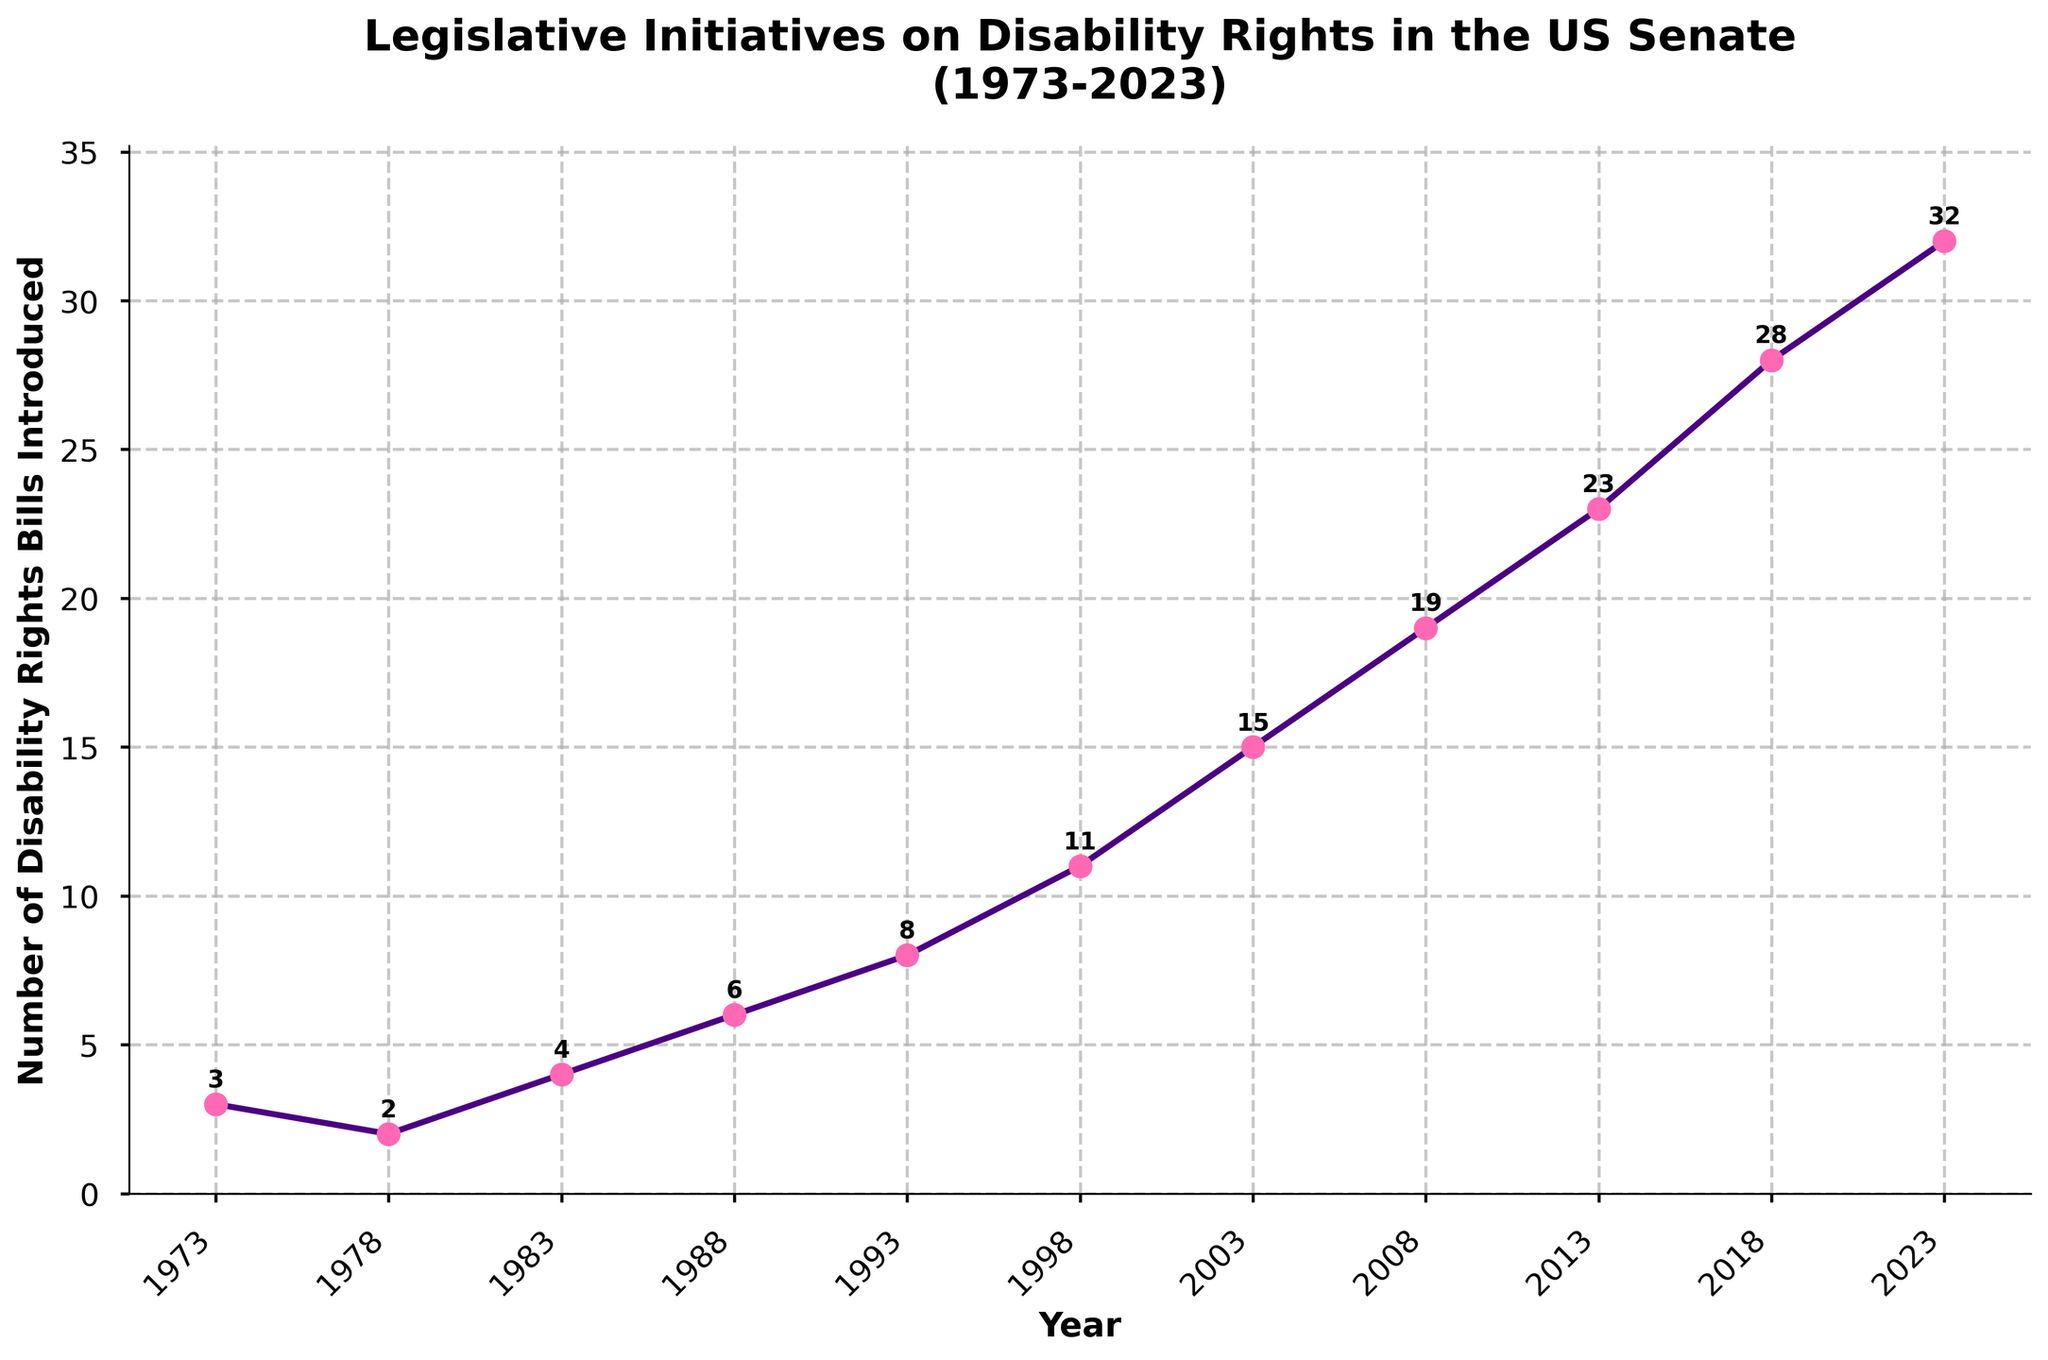What is the total number of disability rights bills introduced from 1973 to 2023? Sum the values of all the introduced bills: (3 + 2 + 4 + 6 + 8 + 11 + 15 + 19 + 23 + 28 + 32) = 151.
Answer: 151 Which year saw the highest number of disability rights bills introduced? Identify the highest value in the dataset and note its corresponding year. The highest value is 32, which occurred in 2023.
Answer: 2023 How many more bills were introduced in 2023 compared to 1983? Subtract the number of bills in 1983 from the number in 2023: 32 - 4 = 28.
Answer: 28 On average, how many bills were introduced per decade according to the data provided? Determine the total number of bills (151) and count the decades (5: 1970s, 1980s, 1990s, 2000s, 2010s). Then, divide the total number of bills by the number of decades: 151 / 5 = 30.2.
Answer: 30.2 Did the number of bills introduced in 1993 exceed double the number introduced in 1973? First double the number of bills in 1973: 3 * 2 = 6. Then, compare it to the bills in 1993, which is 8. Since 8 > 6, the answer is yes.
Answer: Yes What is the rate of increase in the number of disability rights bills introduced between 1988 and 2023? First find the number of bills in 1988 and 2023, which are 6 and 32, respectively. The rate of increase is (32 - 6) / (2023 - 1988) = 26 / 35 ≈ 0.74 bills per year.
Answer: 0.74 bills per year Which period had the largest increase in the number of disability rights bills introduced, 1983 to 1988 or 2018 to 2023? Calculate the difference for each period: 
1983 to 1988: 6 - 4 = 2.
2018 to 2023: 32 - 28 = 4.
Since 4 > 2, the 2018 to 2023 period had the largest increase.
Answer: 2018 to 2023 What is the difference between the number of bills introduced in the earliest and latest years in the dataset? Subtract the number of bills in 1973 from the number in 2023: 32 - 3 = 29.
Answer: 29 Did any two consecutive data points have the same number of bills introduced? Compare each pair of consecutive values in the dataset: None of the consecutive data points has the same value. All pairs have different values.
Answer: No How does the trend in the number of disability rights bills introduced change over the 50-year period? Observe the general direction of the line: The trend shows a steady increase from 1973 to 2023, indicating a growing focus on disability rights over the years.
Answer: Steady increase 